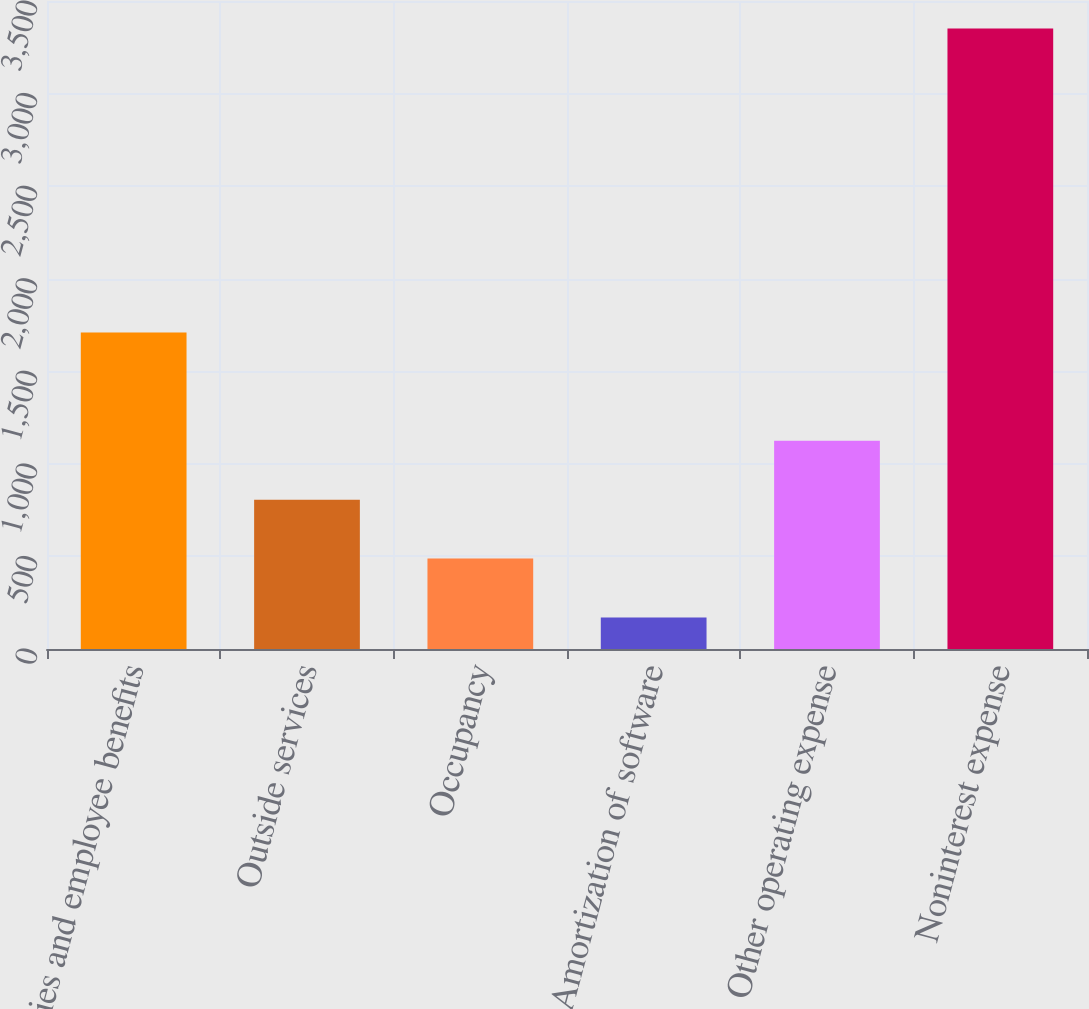Convert chart to OTSL. <chart><loc_0><loc_0><loc_500><loc_500><bar_chart><fcel>Salaries and employee benefits<fcel>Outside services<fcel>Occupancy<fcel>Amortization of software<fcel>Other operating expense<fcel>Noninterest expense<nl><fcel>1709<fcel>806.4<fcel>488.2<fcel>170<fcel>1124.6<fcel>3352<nl></chart> 